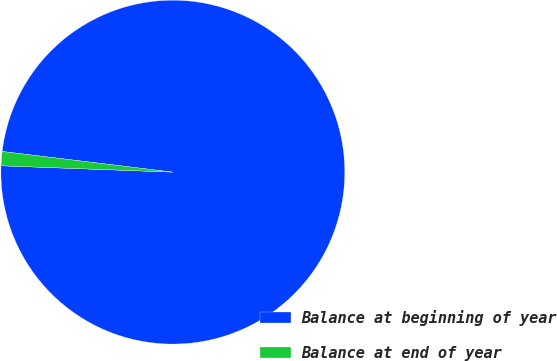Convert chart to OTSL. <chart><loc_0><loc_0><loc_500><loc_500><pie_chart><fcel>Balance at beginning of year<fcel>Balance at end of year<nl><fcel>98.67%<fcel>1.33%<nl></chart> 